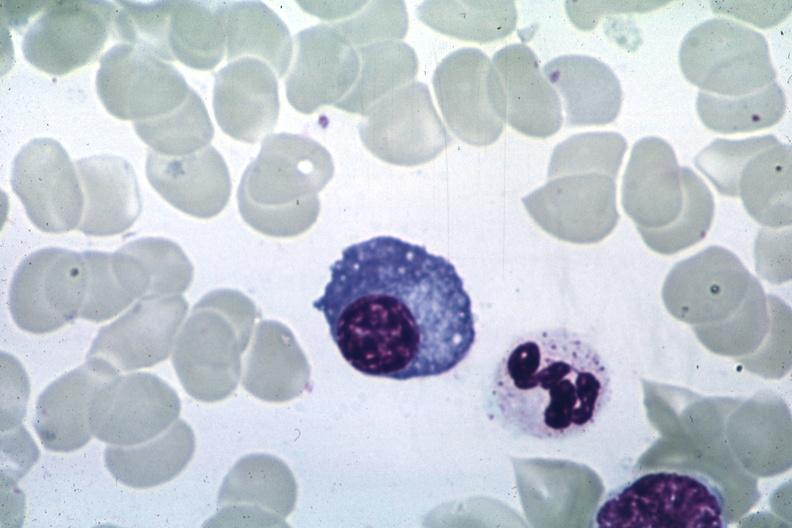s hematologic present?
Answer the question using a single word or phrase. Yes 